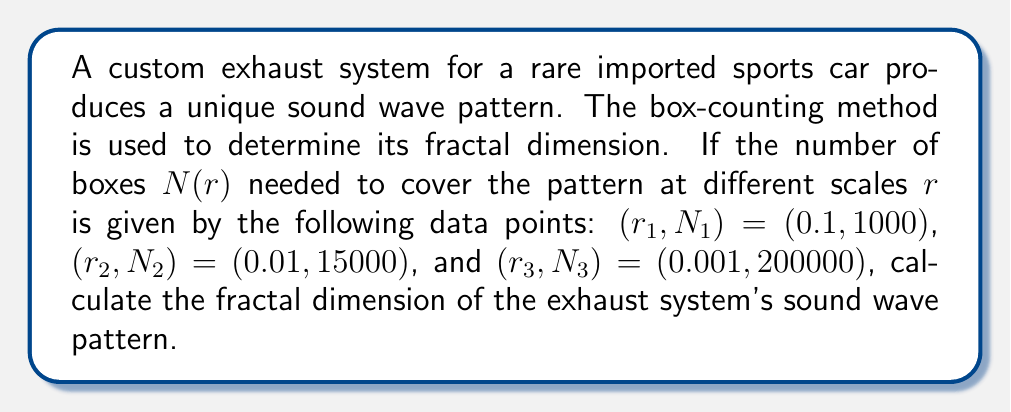Give your solution to this math problem. To calculate the fractal dimension using the box-counting method, we follow these steps:

1) The fractal dimension $D$ is given by the slope of the log-log plot of $N(r)$ vs. $r$.

2) We use the formula:
   $$D = -\lim_{r \to 0} \frac{\log N(r)}{\log r}$$

3) Since we have three data points, we'll use the average slope between them:

4) Calculate slopes between consecutive points:
   
   Slope 1-2: 
   $$D_{12} = -\frac{\log(15000) - \log(1000)}{\log(0.01) - \log(0.1)} = \frac{\log(15)}{1} = 2.7081$$

   Slope 2-3:
   $$D_{23} = -\frac{\log(200000) - \log(15000)}{\log(0.001) - \log(0.01)} = \frac{\log(40/3)}{1} = 2.5850$$

5) Calculate the average of these slopes:
   $$D = \frac{D_{12} + D_{23}}{2} = \frac{2.7081 + 2.5850}{2} = 2.6466$$

Therefore, the fractal dimension of the exhaust system's sound wave pattern is approximately 2.6466.
Answer: 2.6466 